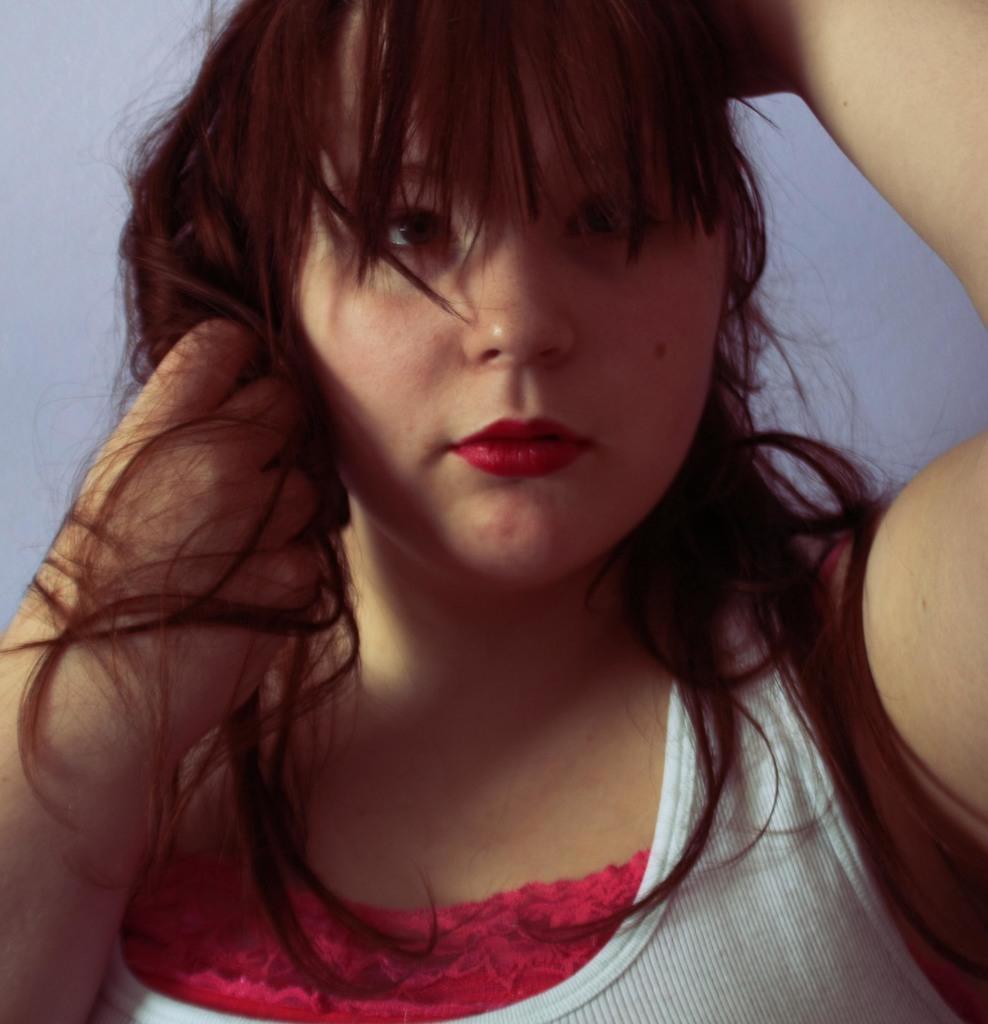Describe this image in one or two sentences. In the image there is a woman in the foreground. 